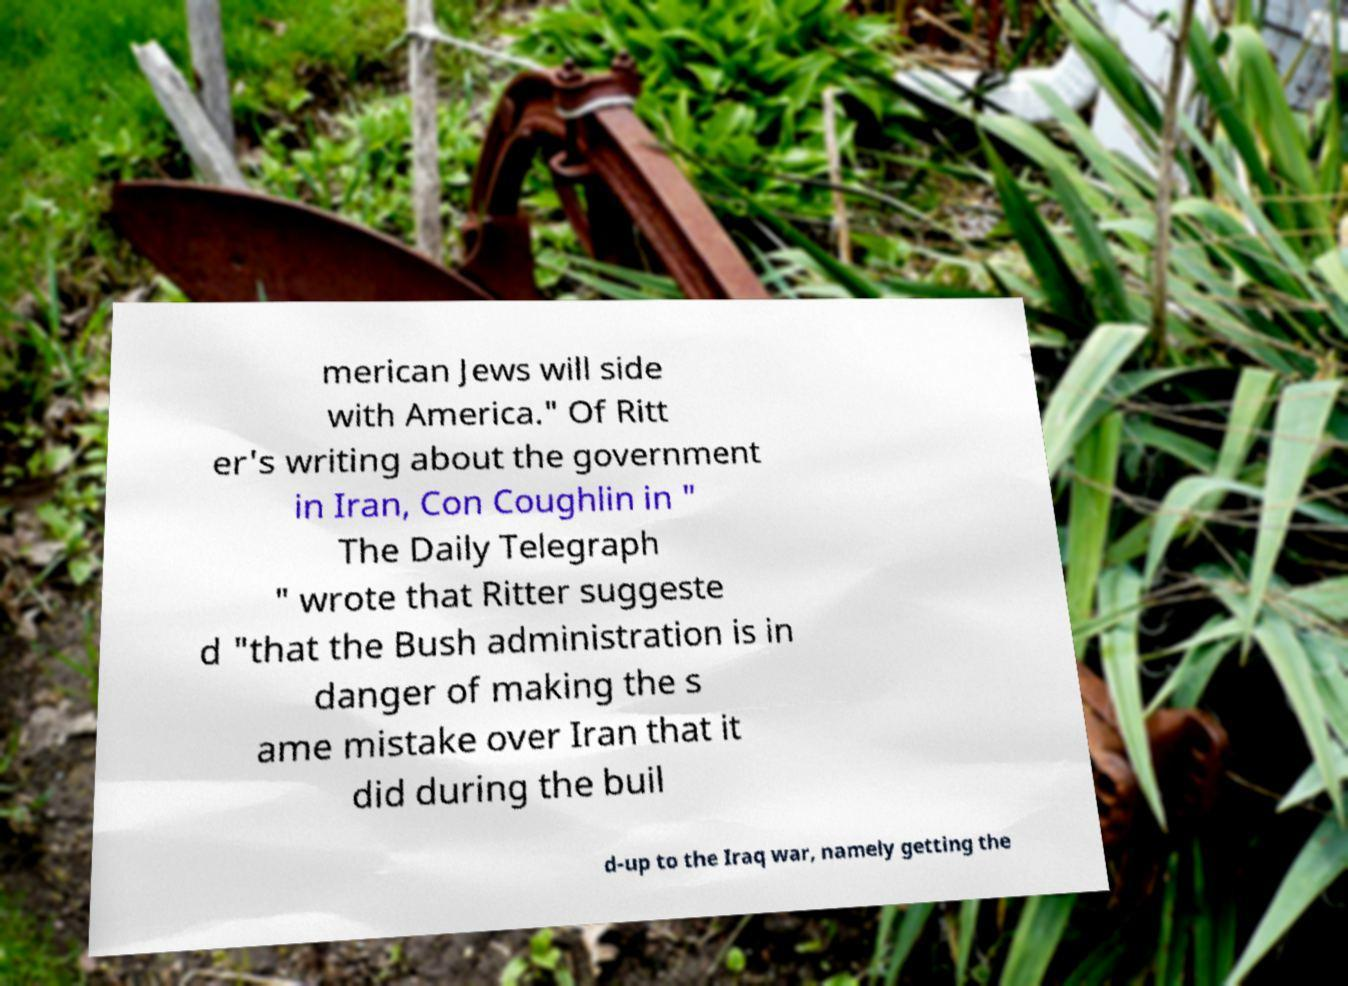There's text embedded in this image that I need extracted. Can you transcribe it verbatim? merican Jews will side with America." Of Ritt er's writing about the government in Iran, Con Coughlin in " The Daily Telegraph " wrote that Ritter suggeste d "that the Bush administration is in danger of making the s ame mistake over Iran that it did during the buil d-up to the Iraq war, namely getting the 